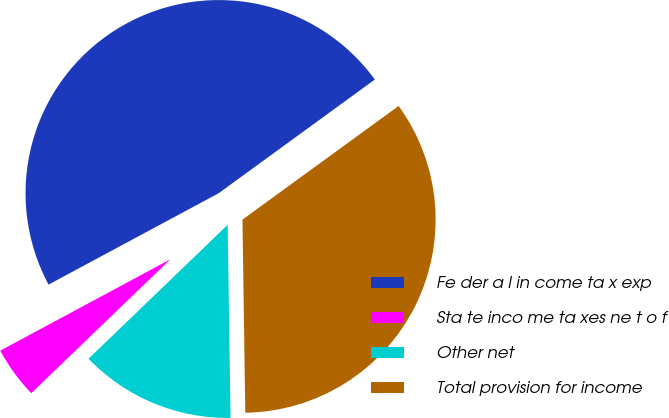<chart> <loc_0><loc_0><loc_500><loc_500><pie_chart><fcel>Fe der a l in come ta x exp<fcel>Sta te inco me ta xes ne t o f<fcel>Other net<fcel>Total provision for income<nl><fcel>47.83%<fcel>4.35%<fcel>13.04%<fcel>34.78%<nl></chart> 